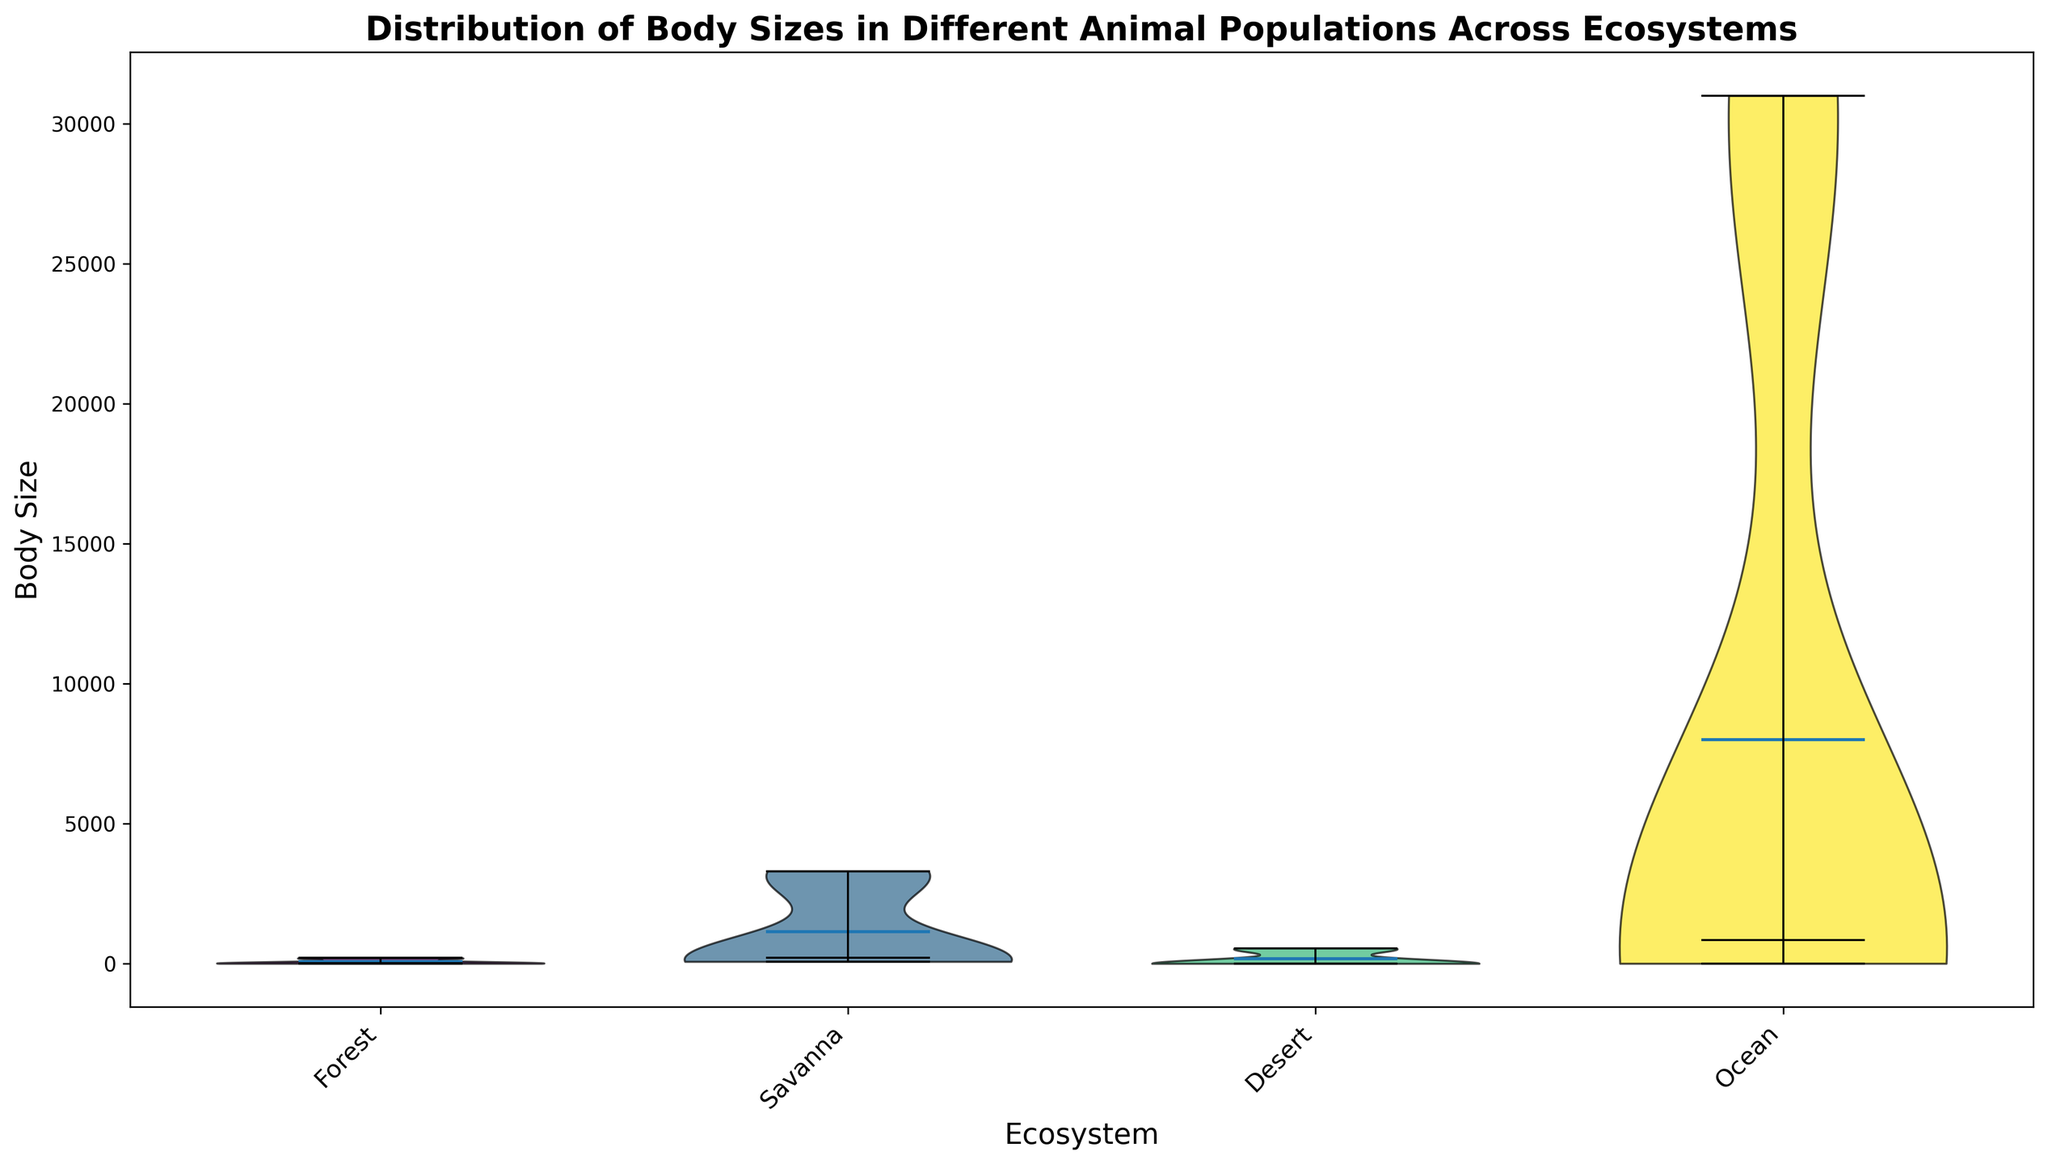Which ecosystem has the widest range of body sizes? By examining the width of the distributions in the violin plot, we can see that the Ocean ecosystem has the widest range of body sizes, varying from very small Crabs to very large Whales.
Answer: Ocean Which ecosystem has the smallest average body size? The average body size is indicated by the location of the mean point in the violin plot. In the Desert ecosystem, the species displayed (Lizard and Scorpion) have the smallest body sizes, making it the ecosystem with the smallest average body size.
Answer: Desert In which ecosystem is the median body size larger, the Forest or Savanna? We compare the location of the median lines (usually a white dot or line) in the violin plots for the Forest and Savanna ecosystems. The Savanna's median body size lies higher on the plot than that of the Forest, indicating a larger median body size.
Answer: Savanna How do the body sizes of animals in the Forest compare to those in the Desert? Visually inspecting the height and spread of the violin plots for Forest and Desert ecosystems, Forest animals have larger and more varied body sizes compared to Desert animals, which are generally small.
Answer: Forest sizes are larger and more varied Which ecosystem has the most evenly distributed body sizes? An evenly distributed body size is indicated by a relatively symmetrical and uniformly filled violin plot. The Ocean ecosystem has a relatively balanced and symmetrical distribution, suggesting the most even distribution of body sizes.
Answer: Ocean Is there any overlap in body sizes between the Desert and Savanna ecosystems? By visually comparing the ranges (heights) of the Desert and Savanna violin plots, we see no overlap between the small-bodied Desert species and larger-bodied Savanna species.
Answer: No overlap Which ecosystem's body size distribution shows an outlier? Outliers can be detected by observing the extremes of the violin plots. The Savanna ecosystem shows an outlier in the upper extreme, likely due to the Elephant’s large body size being much greater than other animals in this ecosystem.
Answer: Savanna What can be inferred about the variation in body sizes of animals in the Forest compared to the Ocean? Variation can be inferred by the spread or width of the violin plots. The Forest shows relatively small variation as compared to the Ocean, which has a broader distribution indicating high variation.
Answer: Ocean has more variation 